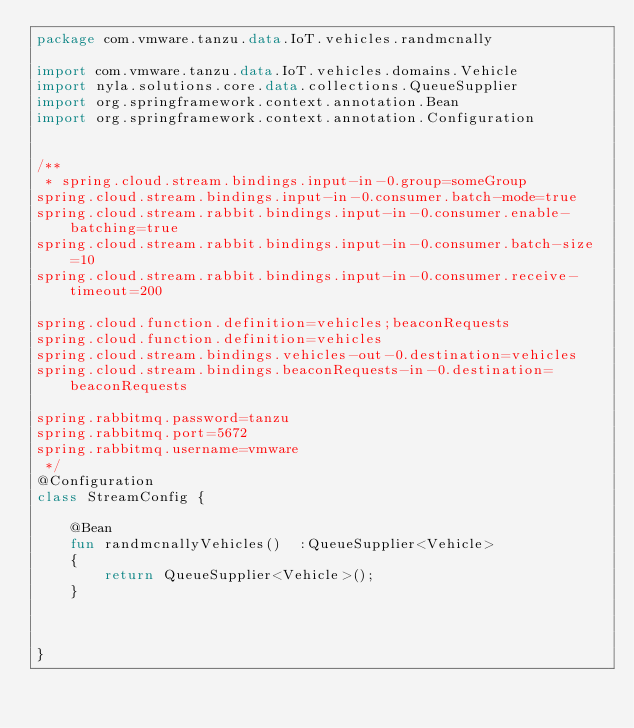<code> <loc_0><loc_0><loc_500><loc_500><_Kotlin_>package com.vmware.tanzu.data.IoT.vehicles.randmcnally

import com.vmware.tanzu.data.IoT.vehicles.domains.Vehicle
import nyla.solutions.core.data.collections.QueueSupplier
import org.springframework.context.annotation.Bean
import org.springframework.context.annotation.Configuration


/**
 * spring.cloud.stream.bindings.input-in-0.group=someGroup
spring.cloud.stream.bindings.input-in-0.consumer.batch-mode=true
spring.cloud.stream.rabbit.bindings.input-in-0.consumer.enable-batching=true
spring.cloud.stream.rabbit.bindings.input-in-0.consumer.batch-size=10
spring.cloud.stream.rabbit.bindings.input-in-0.consumer.receive-timeout=200

spring.cloud.function.definition=vehicles;beaconRequests
spring.cloud.function.definition=vehicles
spring.cloud.stream.bindings.vehicles-out-0.destination=vehicles
spring.cloud.stream.bindings.beaconRequests-in-0.destination=beaconRequests

spring.rabbitmq.password=tanzu
spring.rabbitmq.port=5672
spring.rabbitmq.username=vmware
 */
@Configuration
class StreamConfig {

    @Bean
    fun randmcnallyVehicles()  :QueueSupplier<Vehicle>
    {
        return QueueSupplier<Vehicle>();
    }



}</code> 